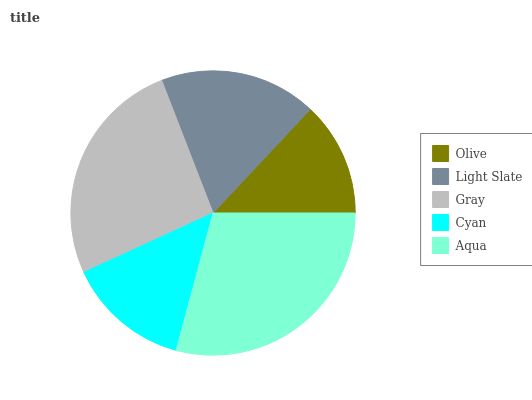Is Olive the minimum?
Answer yes or no. Yes. Is Aqua the maximum?
Answer yes or no. Yes. Is Light Slate the minimum?
Answer yes or no. No. Is Light Slate the maximum?
Answer yes or no. No. Is Light Slate greater than Olive?
Answer yes or no. Yes. Is Olive less than Light Slate?
Answer yes or no. Yes. Is Olive greater than Light Slate?
Answer yes or no. No. Is Light Slate less than Olive?
Answer yes or no. No. Is Light Slate the high median?
Answer yes or no. Yes. Is Light Slate the low median?
Answer yes or no. Yes. Is Gray the high median?
Answer yes or no. No. Is Gray the low median?
Answer yes or no. No. 